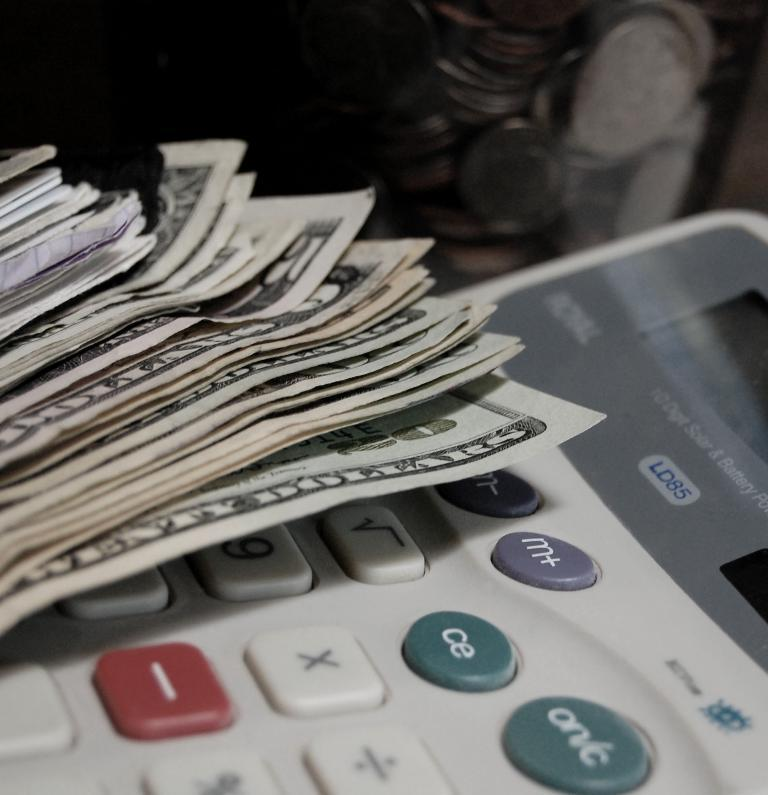<image>
Present a compact description of the photo's key features. A calculator is underneath a pile of 20 and 5 dollar bills. 